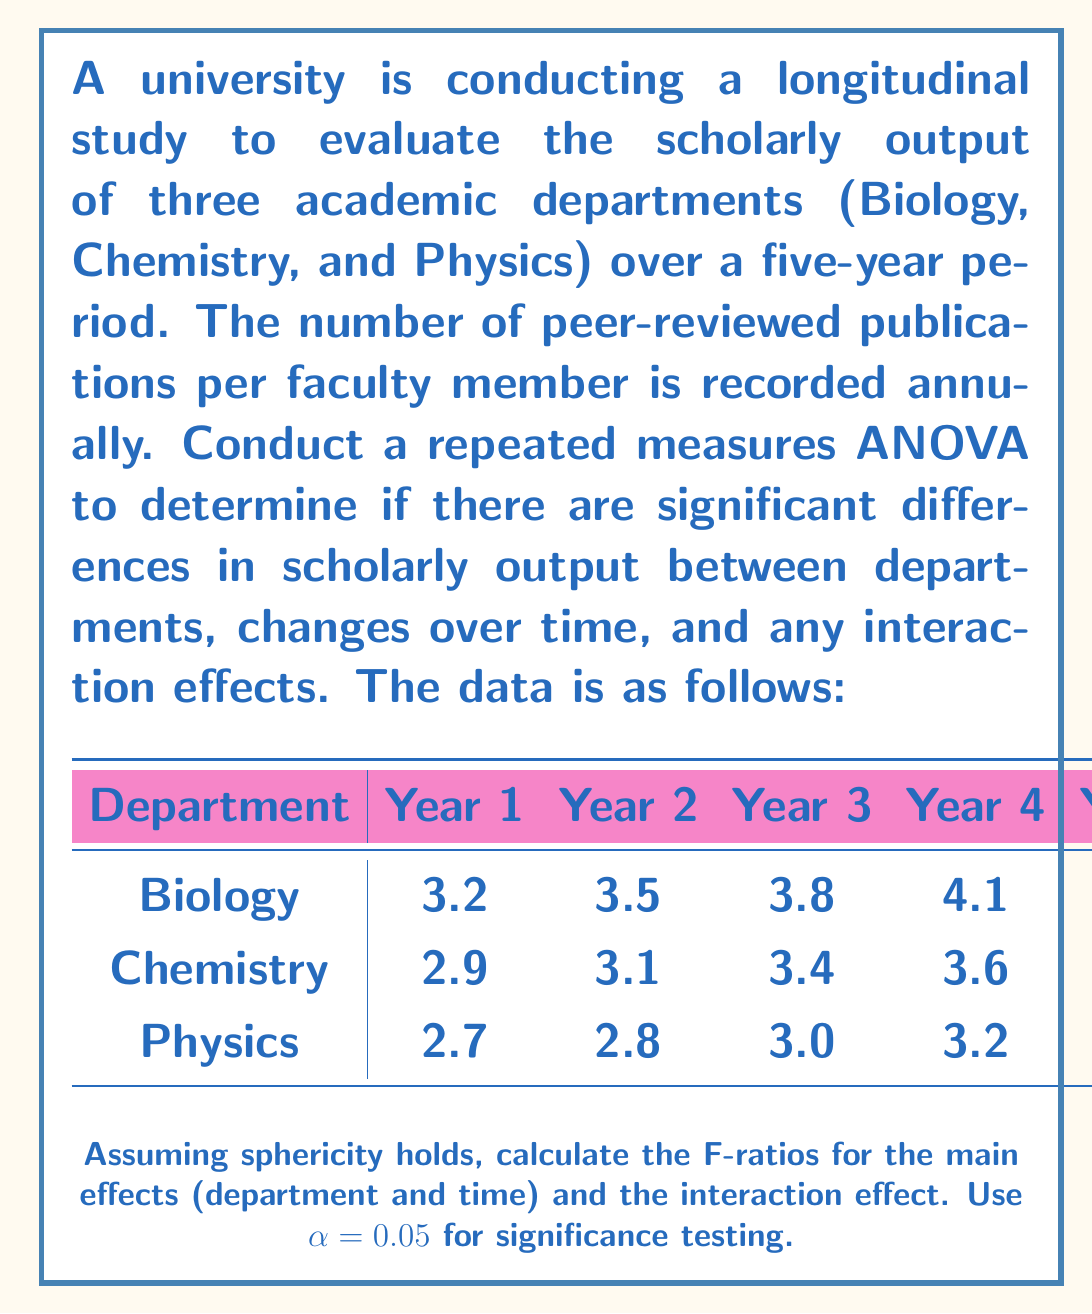Can you solve this math problem? To solve this problem, we will follow these steps:

1. Calculate the sums of squares for departments (SS$_D$), time (SS$_T$), interaction (SS$_{DT}$), and error (SS$_E$).
2. Calculate the degrees of freedom for each source of variation.
3. Compute the mean squares for each source of variation.
4. Calculate the F-ratios and compare them to the critical F-values.

Step 1: Calculate sums of squares

First, we need to calculate the total sum of squares (SS$_{total}$), which is the sum of squared deviations from the grand mean.

Grand mean = $\frac{54}{15} = 3.6$

SS$_{total} = \sum_{i=1}^3 \sum_{j=1}^5 (X_{ij} - \bar{X})^2 = 5.636$

Next, we calculate the sum of squares for departments (SS$_D$):

SS$_D = 5 \sum_{i=1}^3 (\bar{X}_i - \bar{X})^2 = 1.708$

Sum of squares for time (SS$_T$):

SS$_T = 3 \sum_{j=1}^5 (\bar{X}_j - \bar{X})^2 = 3.256$

Sum of squares for interaction (SS$_{DT}$):

SS$_{DT} = \sum_{i=1}^3 \sum_{j=1}^5 (X_{ij} - \bar{X}_i - \bar{X}_j + \bar{X})^2 = 0.092$

Sum of squares for error (SS$_E$):

SS$_E = \text{SS}_{total} - \text{SS}_D - \text{SS}_T - \text{SS}_{DT} = 0.58$

Step 2: Calculate degrees of freedom

df$_D = 3 - 1 = 2$
df$_T = 5 - 1 = 4$
df$_{DT} = (3-1)(5-1) = 8$
df$_E = (3-1)(5-1) = 8$

Step 3: Compute mean squares

MS$_D = \frac{\text{SS}_D}{\text{df}_D} = \frac{1.708}{2} = 0.854$
MS$_T = \frac{\text{SS}_T}{\text{df}_T} = \frac{3.256}{4} = 0.814$
MS$_{DT} = \frac{\text{SS}_{DT}}{\text{df}_{DT}} = \frac{0.092}{8} = 0.0115$
MS$_E = \frac{\text{SS}_E}{\text{df}_E} = \frac{0.58}{8} = 0.0725$

Step 4: Calculate F-ratios

F$_D = \frac{\text{MS}_D}{\text{MS}_E} = \frac{0.854}{0.0725} = 11.78$
F$_T = \frac{\text{MS}_T}{\text{MS}_E} = \frac{0.814}{0.0725} = 11.23$
F$_{DT} = \frac{\text{MS}_{DT}}{\text{MS}_E} = \frac{0.0115}{0.0725} = 0.159$

Critical F-values (at $\alpha = 0.05$):
F$_{crit(2,8)} = 4.46$
F$_{crit(4,8)} = 3.84$
F$_{crit(8,8)} = 3.44$

Comparing the calculated F-ratios to the critical F-values:

F$_D > \text{F}_{crit(2,8)}$, so there is a significant difference between departments.
F$_T > \text{F}_{crit(4,8)}$, so there is a significant change over time.
F$_{DT} < \text{F}_{crit(8,8)}$, so there is no significant interaction effect.
Answer: F-ratios:
Department: F$_D = 11.78$
Time: F$_T = 11.23$
Interaction: F$_{DT} = 0.159$

Significant effects:
- Significant difference between departments (p < 0.05)
- Significant change over time (p < 0.05)
- No significant interaction effect (p > 0.05) 